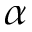Convert formula to latex. <formula><loc_0><loc_0><loc_500><loc_500>\alpha</formula> 